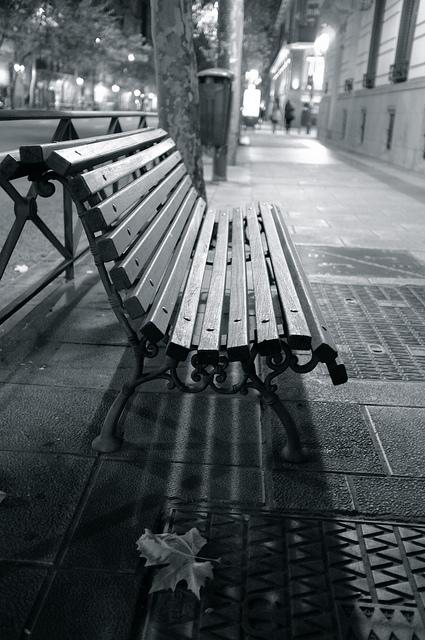Is the bench in a park?
Short answer required. No. Is the bench in use?
Concise answer only. No. Was the photo taken at night?
Keep it brief. Yes. 